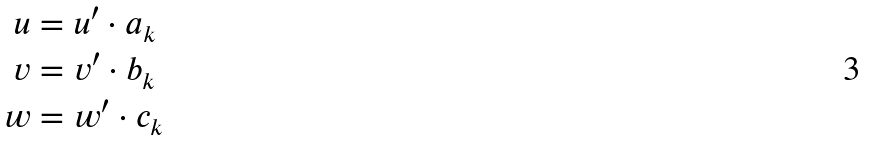<formula> <loc_0><loc_0><loc_500><loc_500>u & = u ^ { \prime } \cdot a _ { k } \\ v & = v ^ { \prime } \cdot b _ { k } \\ w & = w ^ { \prime } \cdot c _ { k }</formula> 